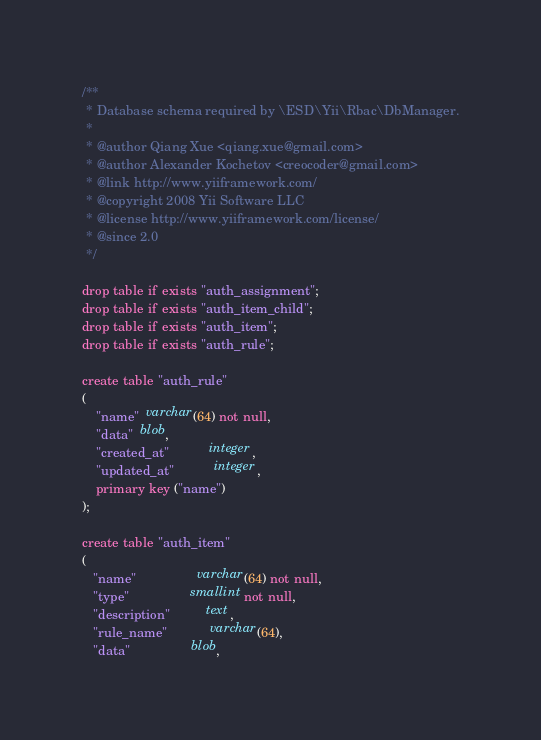Convert code to text. <code><loc_0><loc_0><loc_500><loc_500><_SQL_>/**
 * Database schema required by \ESD\Yii\Rbac\DbManager.
 *
 * @author Qiang Xue <qiang.xue@gmail.com>
 * @author Alexander Kochetov <creocoder@gmail.com>
 * @link http://www.yiiframework.com/
 * @copyright 2008 Yii Software LLC
 * @license http://www.yiiframework.com/license/
 * @since 2.0
 */

drop table if exists "auth_assignment";
drop table if exists "auth_item_child";
drop table if exists "auth_item";
drop table if exists "auth_rule";

create table "auth_rule"
(
    "name"  varchar(64) not null,
    "data"  blob,
    "created_at"           integer,
    "updated_at"           integer,
    primary key ("name")
);

create table "auth_item"
(
   "name"                 varchar(64) not null,
   "type"                 smallint not null,
   "description"          text,
   "rule_name"            varchar(64),
   "data"                 blob,</code> 